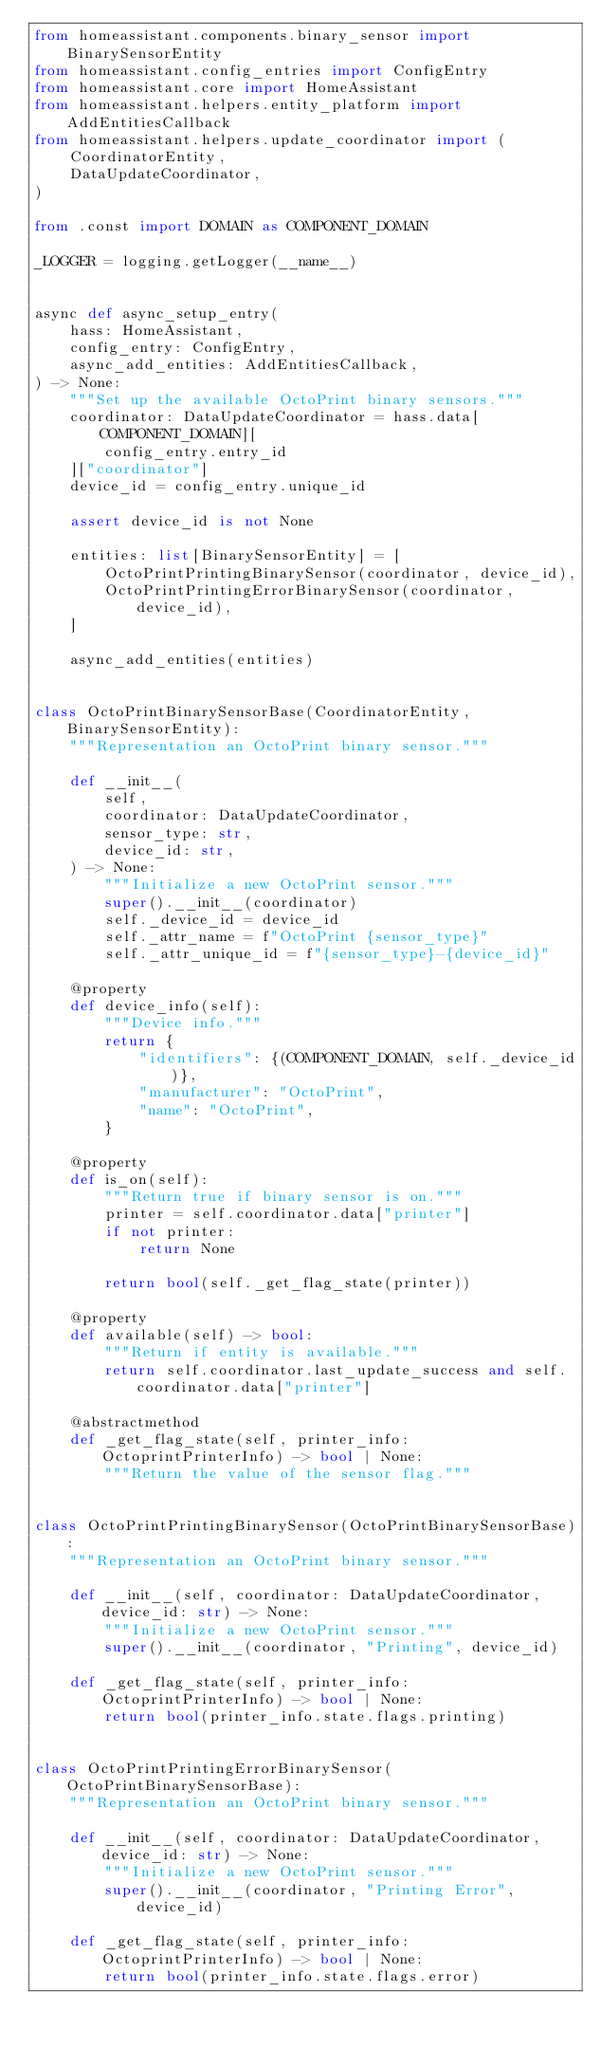<code> <loc_0><loc_0><loc_500><loc_500><_Python_>from homeassistant.components.binary_sensor import BinarySensorEntity
from homeassistant.config_entries import ConfigEntry
from homeassistant.core import HomeAssistant
from homeassistant.helpers.entity_platform import AddEntitiesCallback
from homeassistant.helpers.update_coordinator import (
    CoordinatorEntity,
    DataUpdateCoordinator,
)

from .const import DOMAIN as COMPONENT_DOMAIN

_LOGGER = logging.getLogger(__name__)


async def async_setup_entry(
    hass: HomeAssistant,
    config_entry: ConfigEntry,
    async_add_entities: AddEntitiesCallback,
) -> None:
    """Set up the available OctoPrint binary sensors."""
    coordinator: DataUpdateCoordinator = hass.data[COMPONENT_DOMAIN][
        config_entry.entry_id
    ]["coordinator"]
    device_id = config_entry.unique_id

    assert device_id is not None

    entities: list[BinarySensorEntity] = [
        OctoPrintPrintingBinarySensor(coordinator, device_id),
        OctoPrintPrintingErrorBinarySensor(coordinator, device_id),
    ]

    async_add_entities(entities)


class OctoPrintBinarySensorBase(CoordinatorEntity, BinarySensorEntity):
    """Representation an OctoPrint binary sensor."""

    def __init__(
        self,
        coordinator: DataUpdateCoordinator,
        sensor_type: str,
        device_id: str,
    ) -> None:
        """Initialize a new OctoPrint sensor."""
        super().__init__(coordinator)
        self._device_id = device_id
        self._attr_name = f"OctoPrint {sensor_type}"
        self._attr_unique_id = f"{sensor_type}-{device_id}"

    @property
    def device_info(self):
        """Device info."""
        return {
            "identifiers": {(COMPONENT_DOMAIN, self._device_id)},
            "manufacturer": "OctoPrint",
            "name": "OctoPrint",
        }

    @property
    def is_on(self):
        """Return true if binary sensor is on."""
        printer = self.coordinator.data["printer"]
        if not printer:
            return None

        return bool(self._get_flag_state(printer))

    @property
    def available(self) -> bool:
        """Return if entity is available."""
        return self.coordinator.last_update_success and self.coordinator.data["printer"]

    @abstractmethod
    def _get_flag_state(self, printer_info: OctoprintPrinterInfo) -> bool | None:
        """Return the value of the sensor flag."""


class OctoPrintPrintingBinarySensor(OctoPrintBinarySensorBase):
    """Representation an OctoPrint binary sensor."""

    def __init__(self, coordinator: DataUpdateCoordinator, device_id: str) -> None:
        """Initialize a new OctoPrint sensor."""
        super().__init__(coordinator, "Printing", device_id)

    def _get_flag_state(self, printer_info: OctoprintPrinterInfo) -> bool | None:
        return bool(printer_info.state.flags.printing)


class OctoPrintPrintingErrorBinarySensor(OctoPrintBinarySensorBase):
    """Representation an OctoPrint binary sensor."""

    def __init__(self, coordinator: DataUpdateCoordinator, device_id: str) -> None:
        """Initialize a new OctoPrint sensor."""
        super().__init__(coordinator, "Printing Error", device_id)

    def _get_flag_state(self, printer_info: OctoprintPrinterInfo) -> bool | None:
        return bool(printer_info.state.flags.error)
</code> 